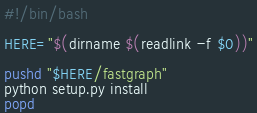Convert code to text. <code><loc_0><loc_0><loc_500><loc_500><_Bash_>#!/bin/bash

HERE="$(dirname $(readlink -f $0))"

pushd "$HERE/fastgraph"
python setup.py install
popd</code> 